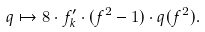<formula> <loc_0><loc_0><loc_500><loc_500>q \mapsto 8 \cdot f ^ { \prime } _ { k } \cdot ( f ^ { 2 } - 1 ) \cdot q ( f ^ { 2 } ) .</formula> 